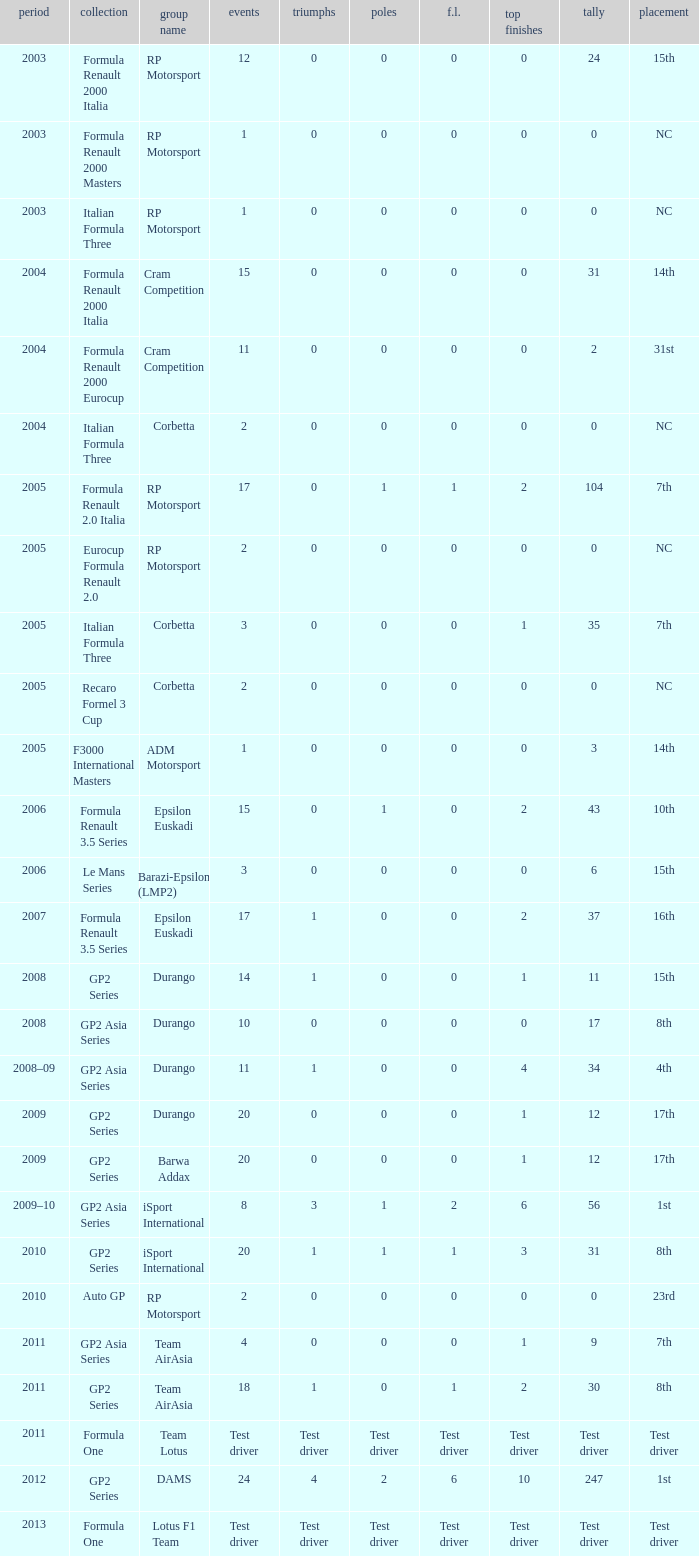What is the number of wins with a 0 F.L., 0 poles, a position of 7th, and 35 points? 0.0. 